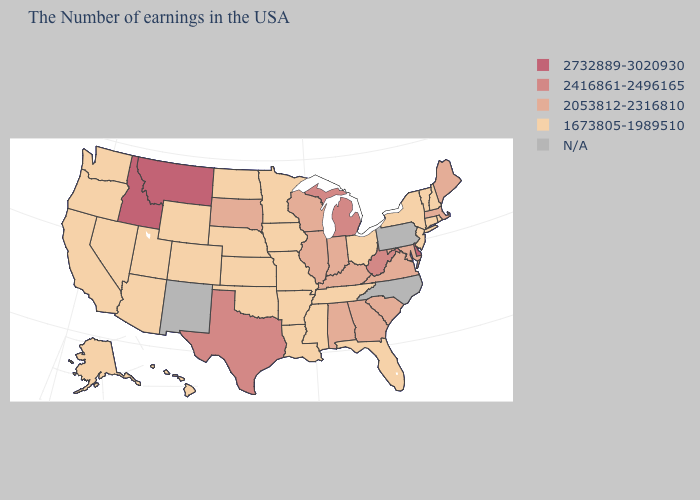What is the value of California?
Keep it brief. 1673805-1989510. Is the legend a continuous bar?
Give a very brief answer. No. What is the lowest value in the USA?
Answer briefly. 1673805-1989510. Among the states that border Ohio , does Kentucky have the highest value?
Keep it brief. No. Name the states that have a value in the range 1673805-1989510?
Answer briefly. Rhode Island, New Hampshire, Vermont, Connecticut, New York, New Jersey, Ohio, Florida, Tennessee, Mississippi, Louisiana, Missouri, Arkansas, Minnesota, Iowa, Kansas, Nebraska, Oklahoma, North Dakota, Wyoming, Colorado, Utah, Arizona, Nevada, California, Washington, Oregon, Alaska, Hawaii. What is the value of Illinois?
Keep it brief. 2053812-2316810. What is the value of Nebraska?
Be succinct. 1673805-1989510. Name the states that have a value in the range 2416861-2496165?
Concise answer only. West Virginia, Michigan, Texas. What is the value of Oregon?
Be succinct. 1673805-1989510. Name the states that have a value in the range N/A?
Write a very short answer. Pennsylvania, North Carolina, New Mexico. What is the highest value in states that border Wisconsin?
Be succinct. 2416861-2496165. What is the value of Missouri?
Be succinct. 1673805-1989510. What is the value of Oklahoma?
Answer briefly. 1673805-1989510. 